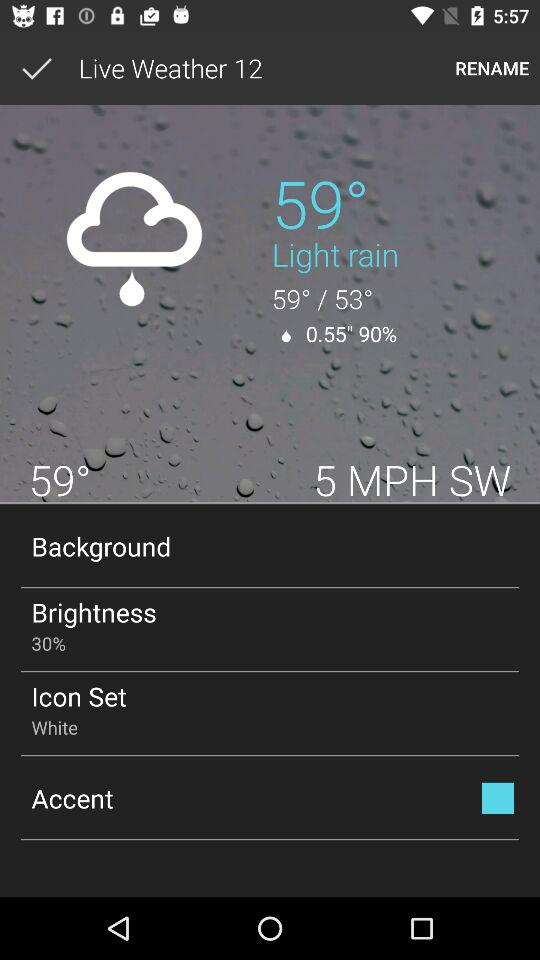What is the temperature? The temperatures are 59° and 53°. 